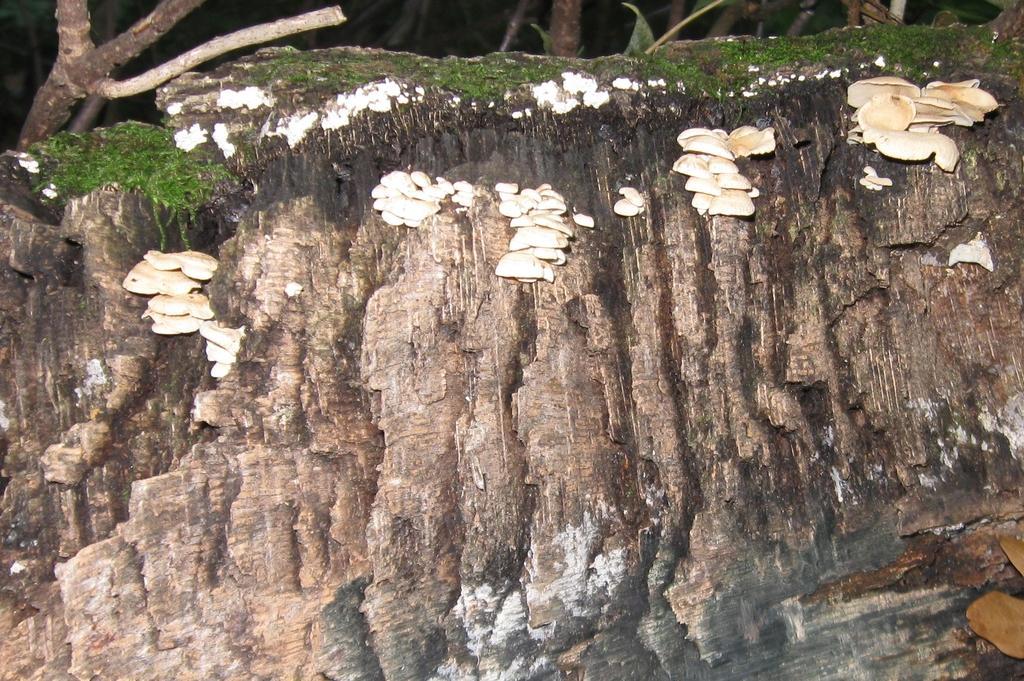Could you give a brief overview of what you see in this image? There are mushrooms on a wall. In the back there are trees. 